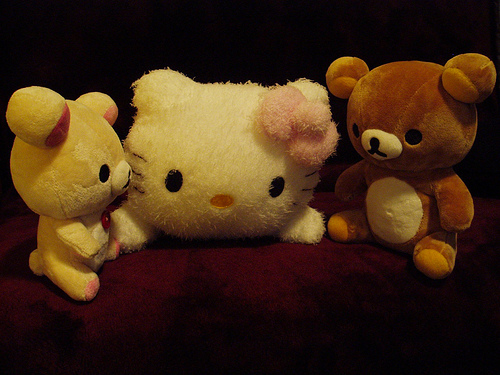<image>Which teddy bear is wearing a ribbon? I am not sure which teddy bear is wearing a ribbon. It could be either the one on the left or the one in the middle. Which teddy bear is wearing a ribbon? I don't know which teddy bear is wearing a ribbon. It can be seen on the left, middle or none of them. 